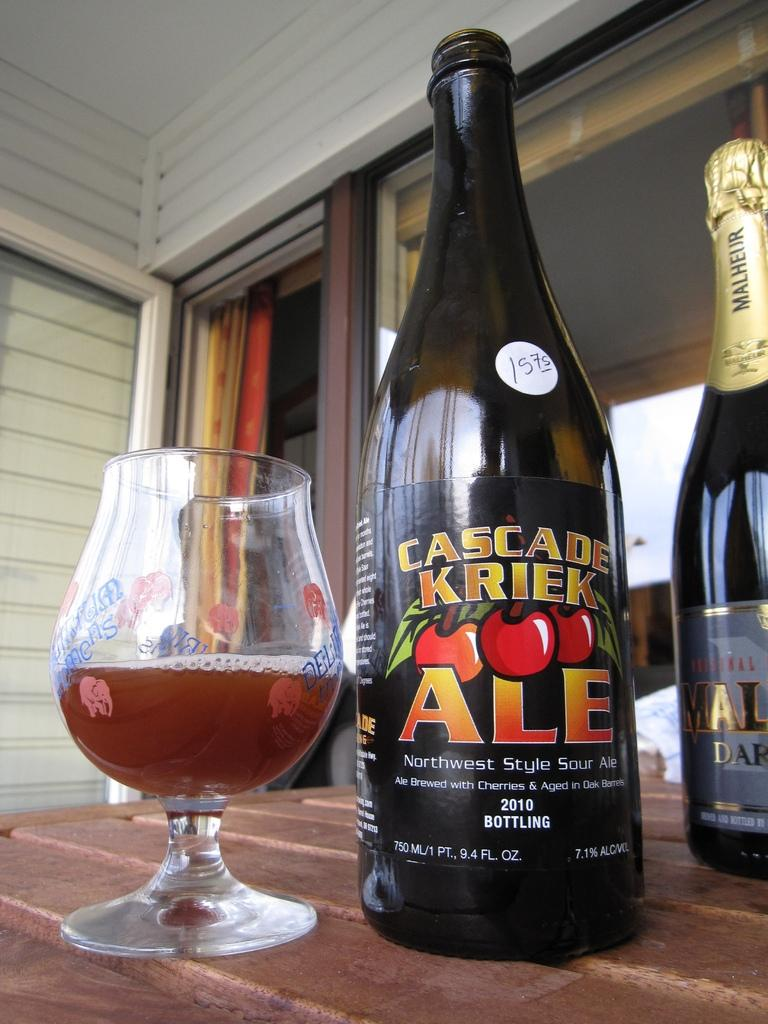Provide a one-sentence caption for the provided image. Cascade Kriek Ale bottle next to a brandy snifter with less than half a glass of the beer on a wooden table outside on a porch. 